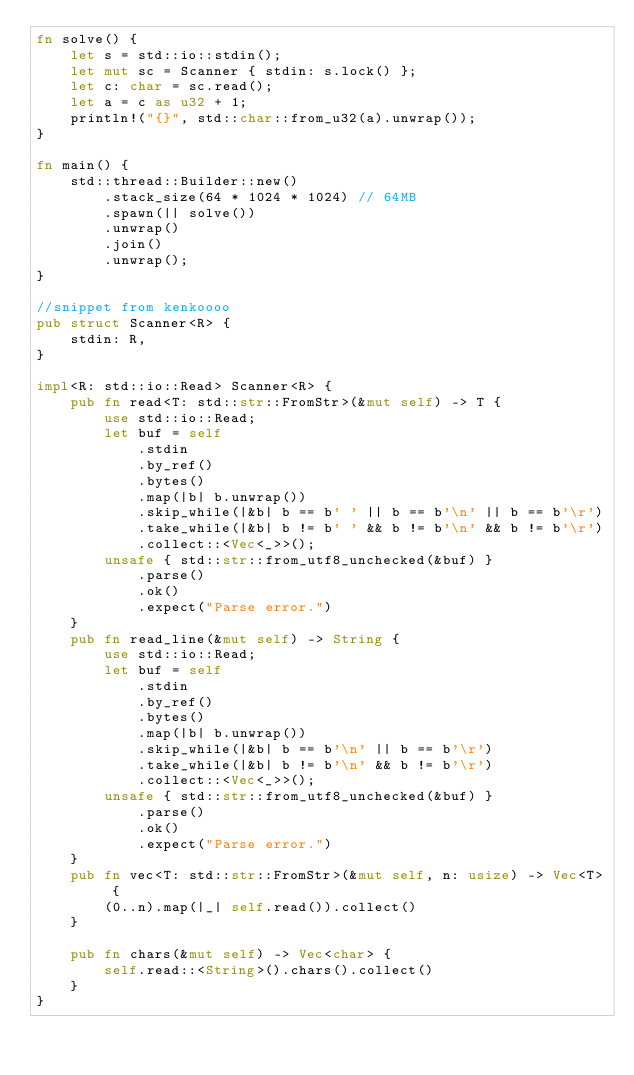<code> <loc_0><loc_0><loc_500><loc_500><_Rust_>fn solve() {
    let s = std::io::stdin();
    let mut sc = Scanner { stdin: s.lock() };
    let c: char = sc.read();
    let a = c as u32 + 1;
    println!("{}", std::char::from_u32(a).unwrap());
}

fn main() {
    std::thread::Builder::new()
        .stack_size(64 * 1024 * 1024) // 64MB
        .spawn(|| solve())
        .unwrap()
        .join()
        .unwrap();
}

//snippet from kenkoooo
pub struct Scanner<R> {
    stdin: R,
}

impl<R: std::io::Read> Scanner<R> {
    pub fn read<T: std::str::FromStr>(&mut self) -> T {
        use std::io::Read;
        let buf = self
            .stdin
            .by_ref()
            .bytes()
            .map(|b| b.unwrap())
            .skip_while(|&b| b == b' ' || b == b'\n' || b == b'\r')
            .take_while(|&b| b != b' ' && b != b'\n' && b != b'\r')
            .collect::<Vec<_>>();
        unsafe { std::str::from_utf8_unchecked(&buf) }
            .parse()
            .ok()
            .expect("Parse error.")
    }
    pub fn read_line(&mut self) -> String {
        use std::io::Read;
        let buf = self
            .stdin
            .by_ref()
            .bytes()
            .map(|b| b.unwrap())
            .skip_while(|&b| b == b'\n' || b == b'\r')
            .take_while(|&b| b != b'\n' && b != b'\r')
            .collect::<Vec<_>>();
        unsafe { std::str::from_utf8_unchecked(&buf) }
            .parse()
            .ok()
            .expect("Parse error.")
    }
    pub fn vec<T: std::str::FromStr>(&mut self, n: usize) -> Vec<T> {
        (0..n).map(|_| self.read()).collect()
    }

    pub fn chars(&mut self) -> Vec<char> {
        self.read::<String>().chars().collect()
    }
}
</code> 